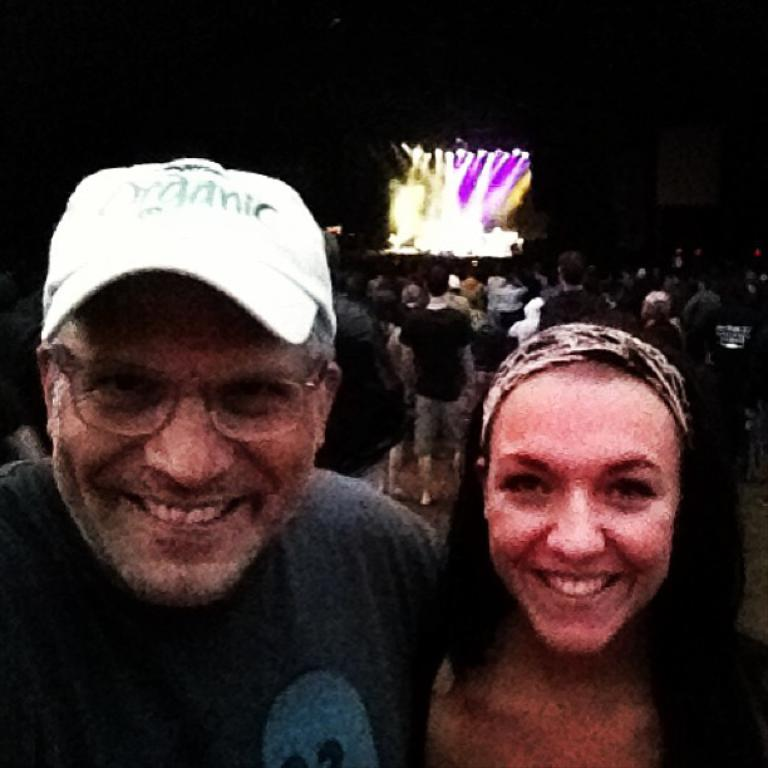What can be seen in the image? There is a group of people in the image. Can you describe the people in the foreground? In the foreground, there is a man and a woman. How are the man and woman in the foreground feeling? The man and woman are both smiling. What can be seen in the background of the image? There are lights visible in the background of the image. What type of cork is being used for the language lesson in the image? There is no cork or language lesson present in the image. What kind of breakfast is being served to the group of people in the image? There is no breakfast being served in the image; it only shows a group of people with a smiling man and woman in the foreground. 